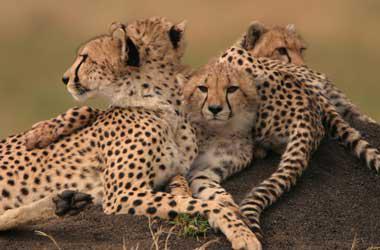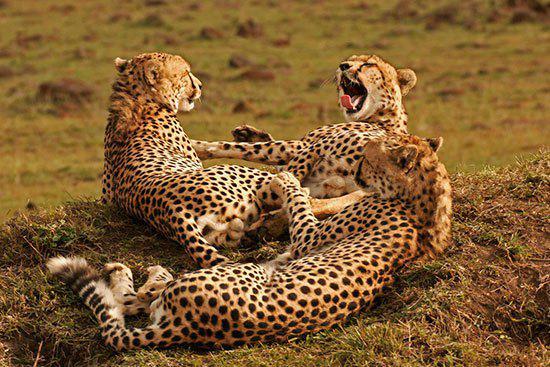The first image is the image on the left, the second image is the image on the right. Analyze the images presented: Is the assertion "There are four leopard’s sitting on a mound of dirt." valid? Answer yes or no. Yes. 